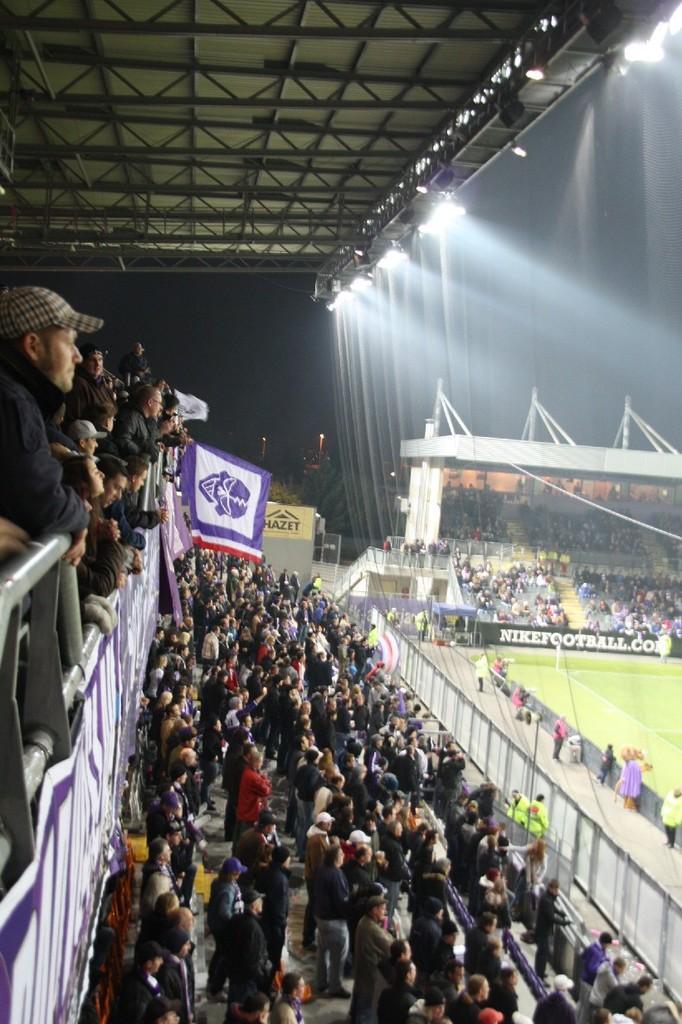Describe this image in one or two sentences. In this image on the left, there is a man, he wears a jacket, cap and there are many people. At the bottom there are many people, ground, posters, flags, fence. At the top there are lights and roof. This is a stadium. 